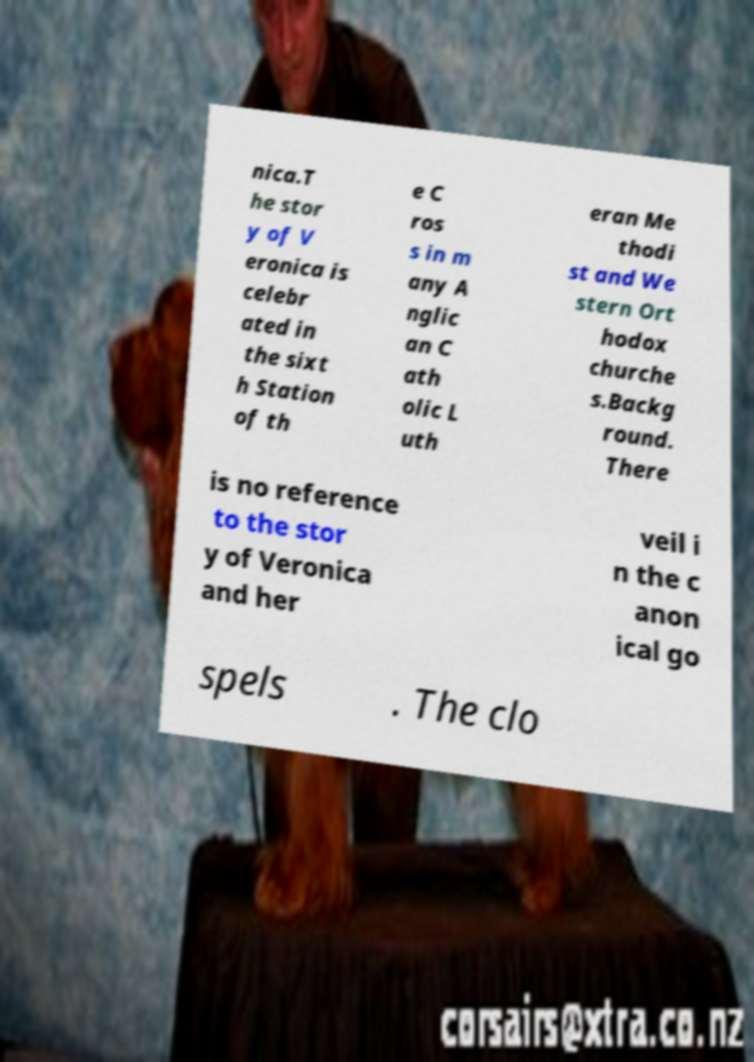Please read and relay the text visible in this image. What does it say? nica.T he stor y of V eronica is celebr ated in the sixt h Station of th e C ros s in m any A nglic an C ath olic L uth eran Me thodi st and We stern Ort hodox churche s.Backg round. There is no reference to the stor y of Veronica and her veil i n the c anon ical go spels . The clo 